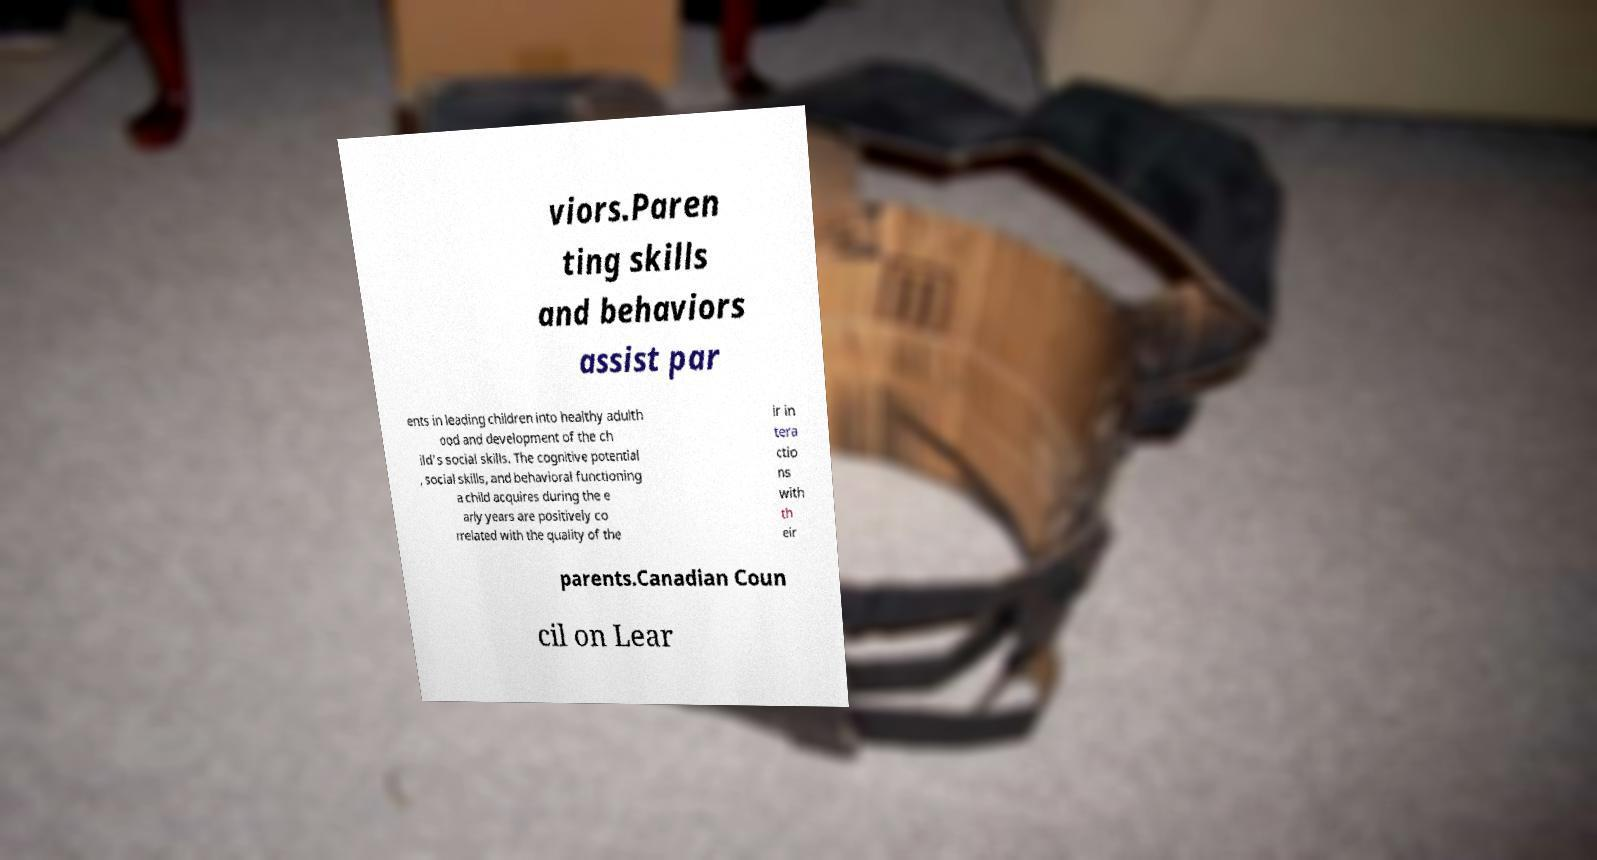Please read and relay the text visible in this image. What does it say? viors.Paren ting skills and behaviors assist par ents in leading children into healthy adulth ood and development of the ch ild's social skills. The cognitive potential , social skills, and behavioral functioning a child acquires during the e arly years are positively co rrelated with the quality of the ir in tera ctio ns with th eir parents.Canadian Coun cil on Lear 